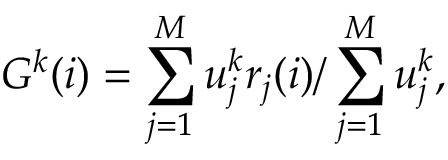Convert formula to latex. <formula><loc_0><loc_0><loc_500><loc_500>G ^ { k } ( i ) = \sum _ { j = 1 } ^ { M } u _ { j } ^ { k } r _ { j } ( i ) / \sum _ { j = 1 } ^ { M } u _ { j } ^ { k } ,</formula> 